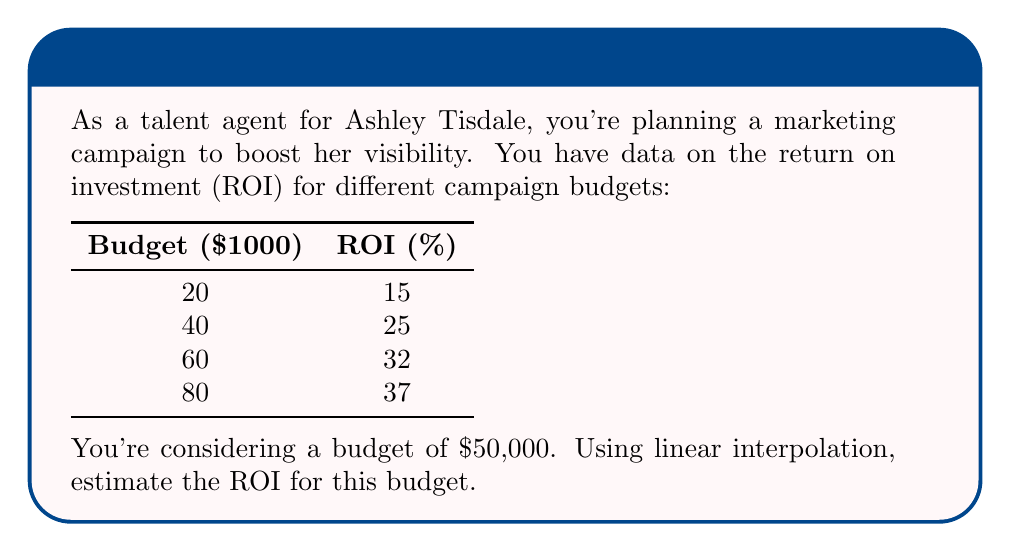Teach me how to tackle this problem. To estimate the ROI for a $50,000 budget using linear interpolation, we follow these steps:

1) First, identify the two known points that bracket our desired value:
   $40,000 budget → 25% ROI
   $60,000 budget → 32% ROI

2) The formula for linear interpolation is:

   $$y = y_1 + \frac{(x - x_1)(y_2 - y_1)}{(x_2 - x_1)}$$

   Where:
   $x$ is our desired input ($50,000)
   $(x_1, y_1)$ is the lower bracketing point (40, 25)
   $(x_2, y_2)$ is the upper bracketing point (60, 32)

3) Plugging in our values:

   $$ROI = 25 + \frac{(50 - 40)(32 - 25)}{(60 - 40)}$$

4) Simplify:
   $$ROI = 25 + \frac{10 \times 7}{20} = 25 + \frac{70}{20} = 25 + 3.5$$

5) Calculate the final result:
   $$ROI = 28.5\%$$

Therefore, the estimated ROI for a $50,000 budget is 28.5%.
Answer: 28.5% 